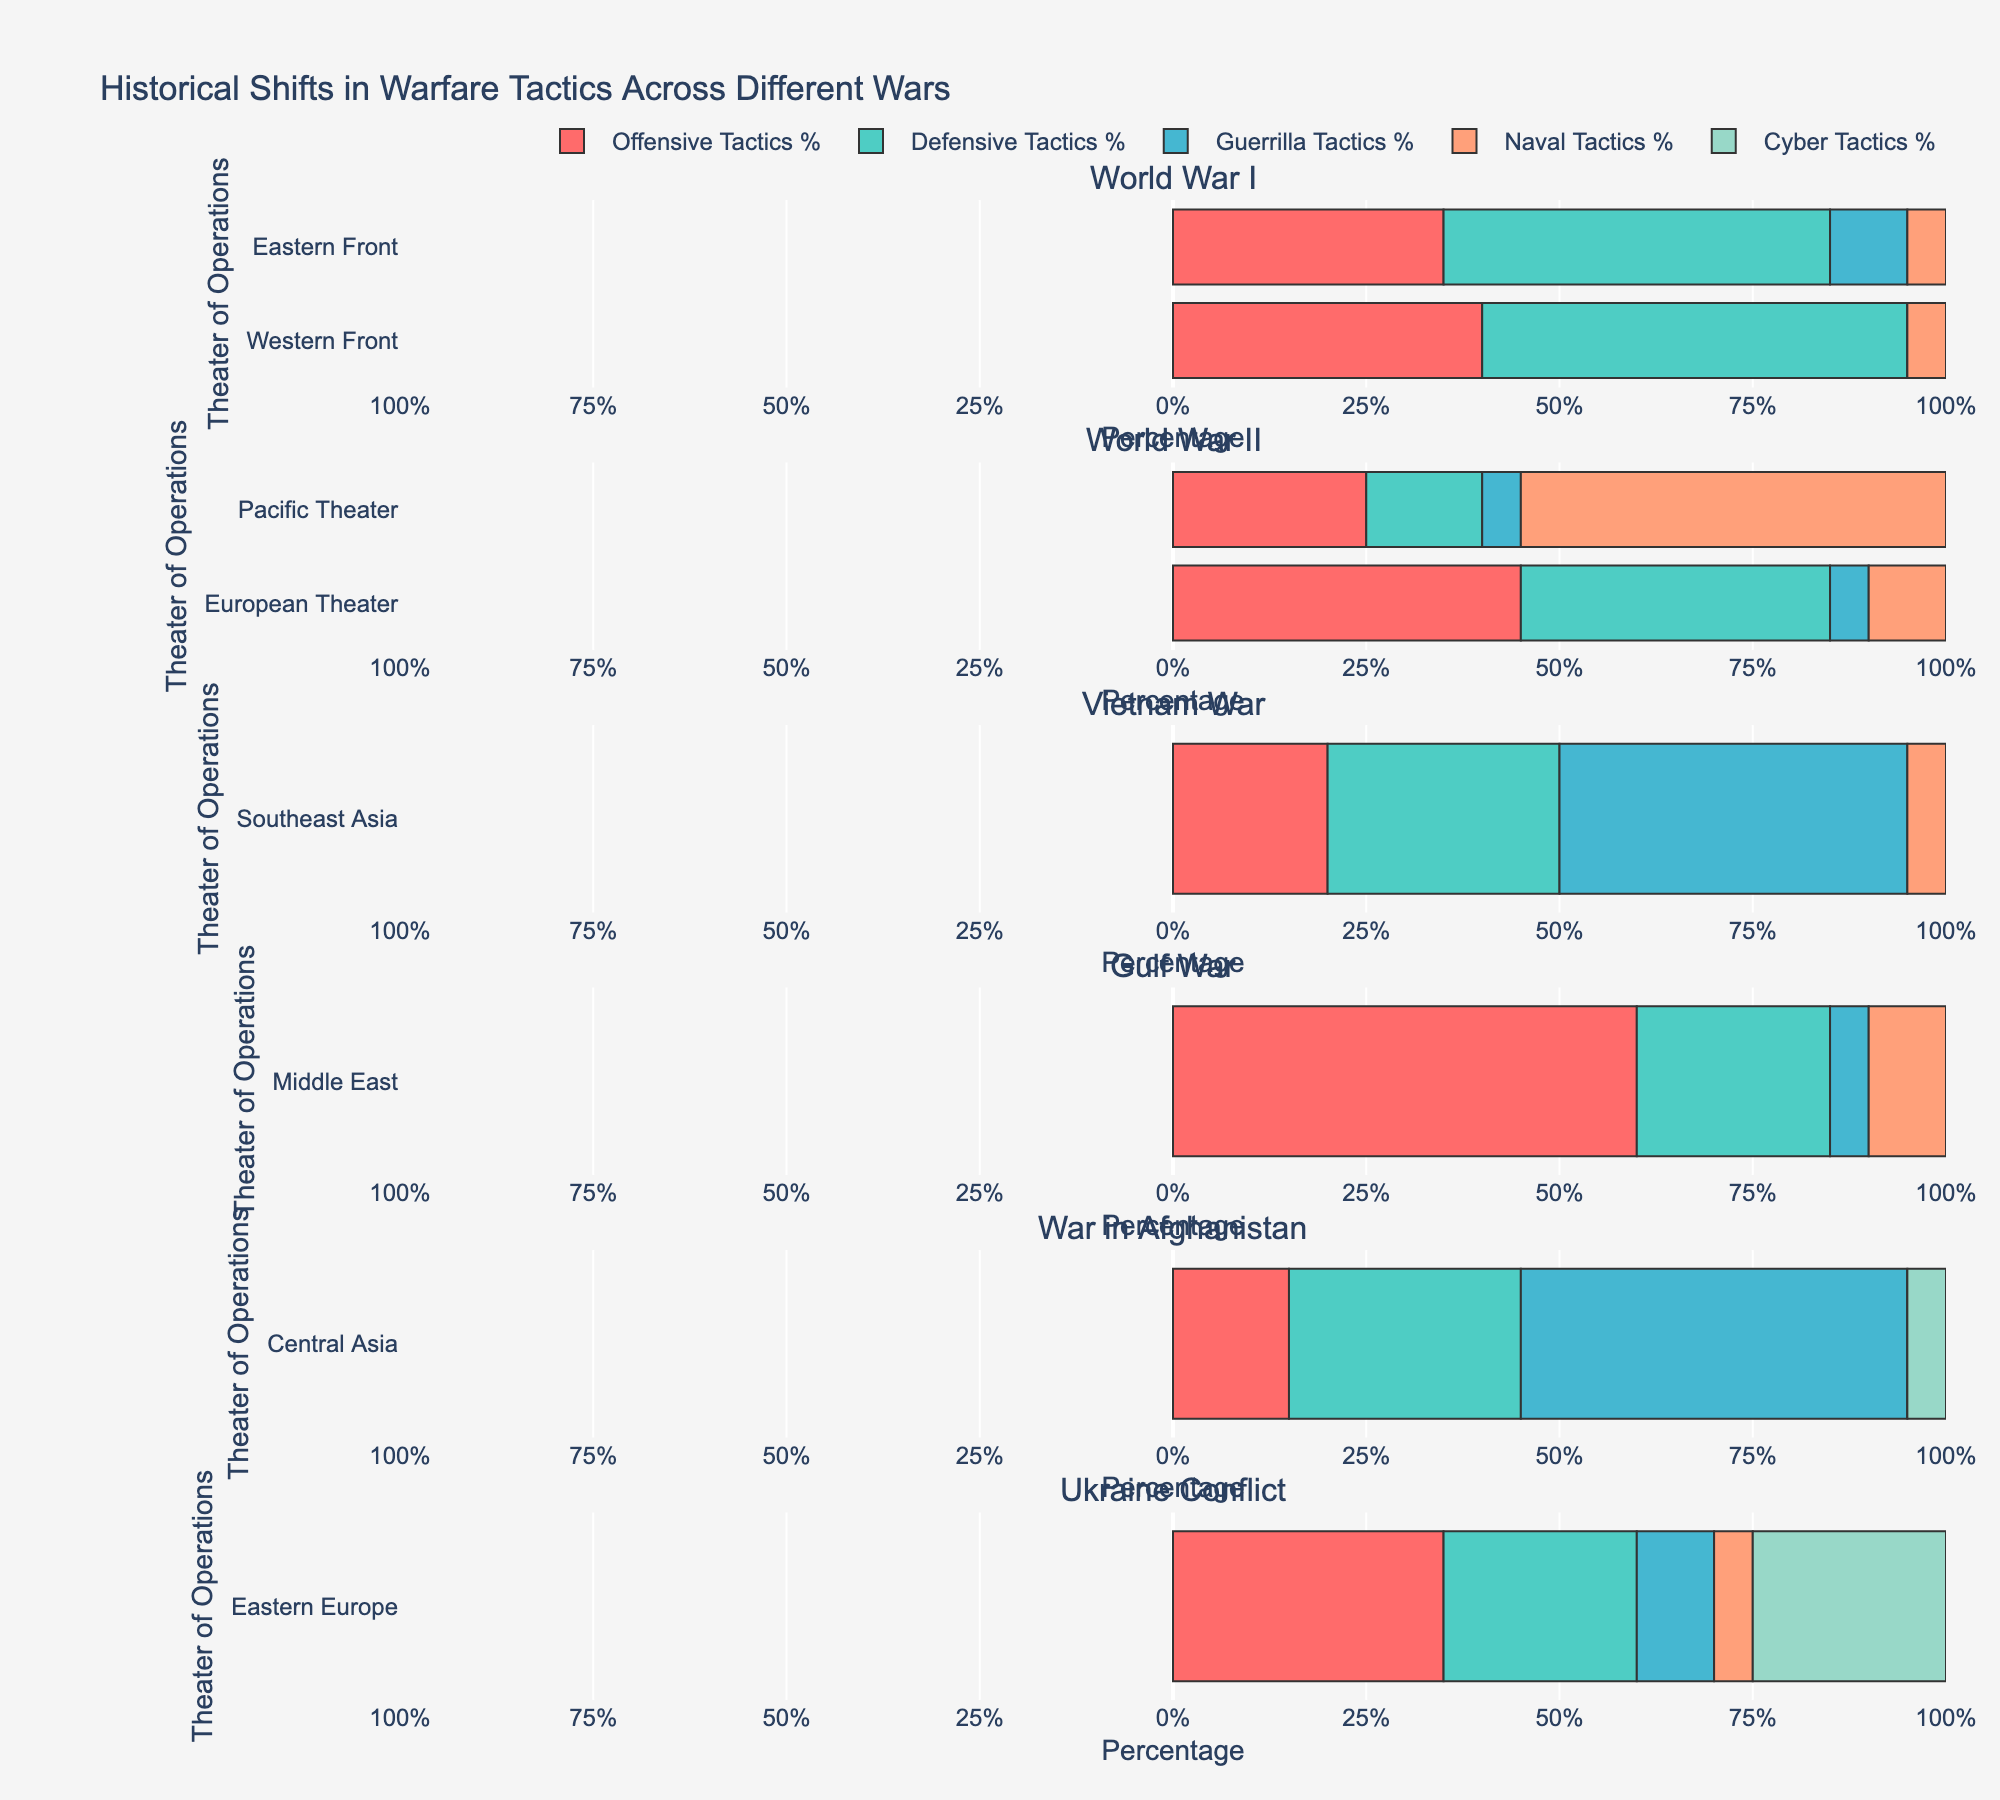What percentage of tactics used in the Pacific Theater during World War II were Naval Tactics? To find this, locate the bar representing Naval Tactics in the Pacific Theater during World War II and note its length. The bar should extend to 55%, indicating that 55% of the tactics were Naval Tactics.
Answer: 55% Which war had the highest use of Guerrilla Tactics? Look at the lengths of the Guerrilla Tactics bars across all wars. Compare the lengths and identify the war with the longest Guerrilla Tactics bar. The Vietnam War has the longest bar at 45%.
Answer: Vietnam War How does the use of Offensive Tactics in the Gulf War compare to the use of Offensive Tactics in the War in Afghanistan? Compare the lengths of the bars representing Offensive Tactics for these two wars. The Gulf War has a bar extending to 60%, whereas the War in Afghanistan has a bar extending only to 15%.
Answer: Greater in the Gulf War What is the combined percentage of Defensive and Cyber Tactics in the Ukraine Conflict? For the Ukraine Conflict, sum the lengths of the bars for Defensive Tactics (25%) and Cyber Tactics (25%). The total is 25% + 25%.
Answer: 50% Which war has the least reliance on Naval Tactics across all theaters? Look at the lengths of all the Naval Tactics bars across the wars. The shortest bars should be at 0%. World War I (Western Front) and the War in Afghanistan have 0% Naval Tactics, indicating no reliance on Naval Tactics.
Answer: World War I (Western Front) and War in Afghanistan What percentage of cyber tactics were used in the Middle East during the Gulf War? Locate the bar labeled Cyber Tactics for the Gulf War in the Middle East. Note its length. Since there is no bar extending for Cyber Tactics, the percentage is 0%.
Answer: 0% Compare the use of Offensive and Defensive Tactics during World War I on the Western Front. Look at the length of the Offensive Tactics bar (40%) and the Defensive Tactics bar (55%) for World War I on the Western Front. Since the Defensive Tactics bar is longer, it indicates that Defensive Tactics were used more.
Answer: Defensive Tactics > Offensive Tactics Which war in the provided data has introduced Cyber Tactics? Scan through the bars for Cyber Tactics across all wars. The only bar indicating the use of Cyber Tactics is in the Ukraine Conflict.
Answer: Ukraine Conflict 